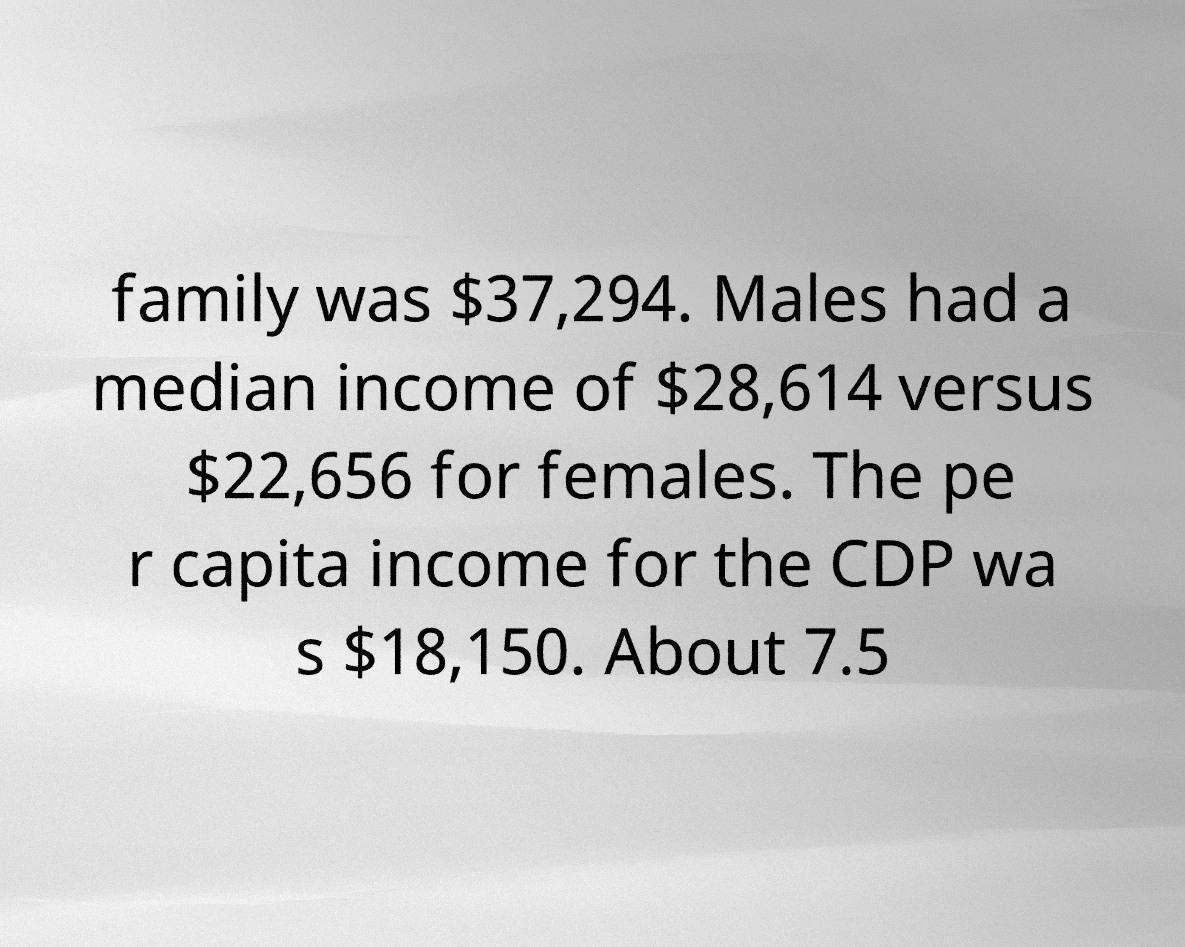Could you extract and type out the text from this image? family was $37,294. Males had a median income of $28,614 versus $22,656 for females. The pe r capita income for the CDP wa s $18,150. About 7.5 